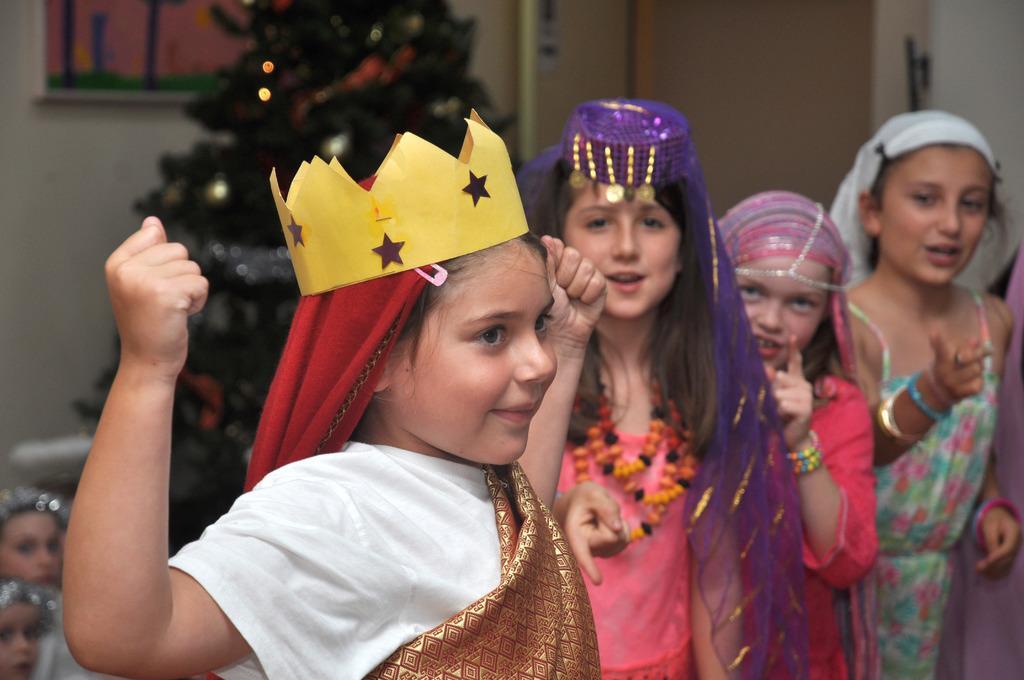Can you describe this image briefly? Girls are standing wearing costumes. The girl at the front is wearing a yellow paper crown and the background is blurred. 